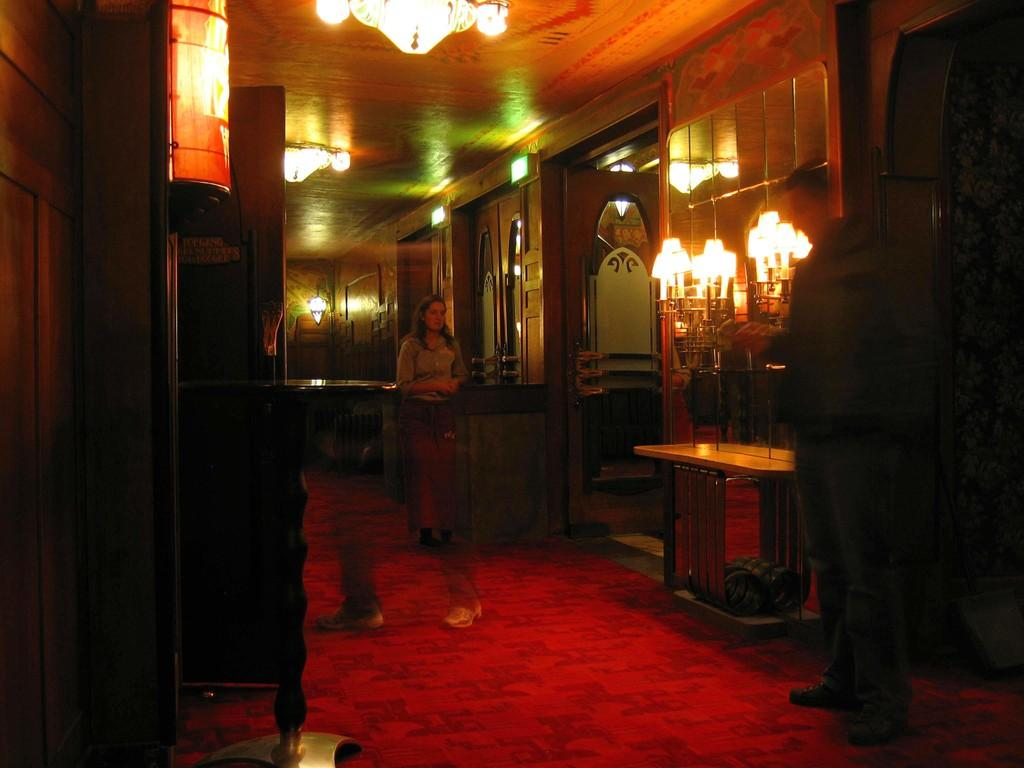How many people are present in the image? There are two men standing in the image. What can be seen in the background of the image? There are lights visible in the image. What architectural feature is present in the image? There is a door in the image. What type of scissors can be seen in the image? There are no scissors present in the image. What kind of ship is visible in the image? There is no ship present in the image. 